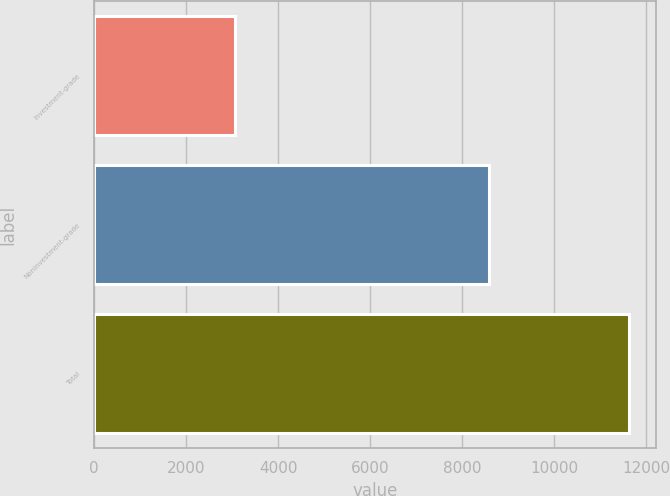Convert chart to OTSL. <chart><loc_0><loc_0><loc_500><loc_500><bar_chart><fcel>Investment-grade<fcel>Noninvestment-grade<fcel>Total<nl><fcel>3055<fcel>8570<fcel>11625<nl></chart> 